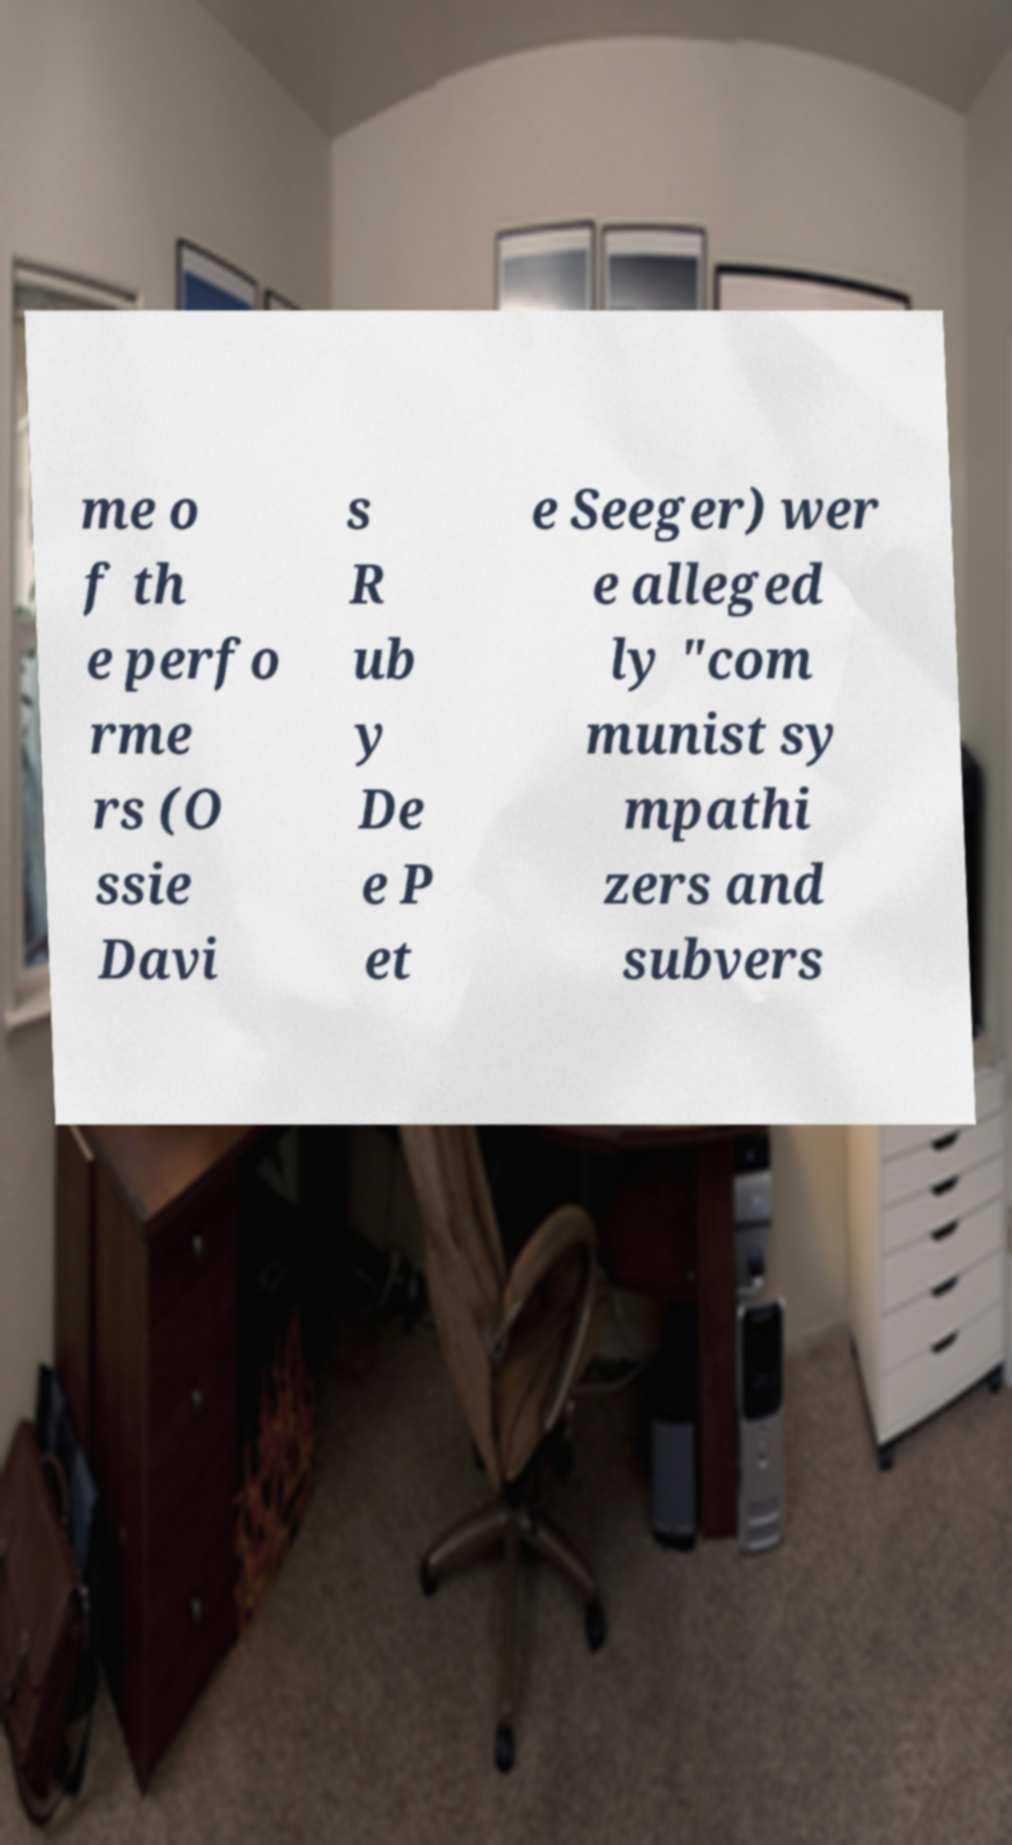Could you extract and type out the text from this image? me o f th e perfo rme rs (O ssie Davi s R ub y De e P et e Seeger) wer e alleged ly "com munist sy mpathi zers and subvers 